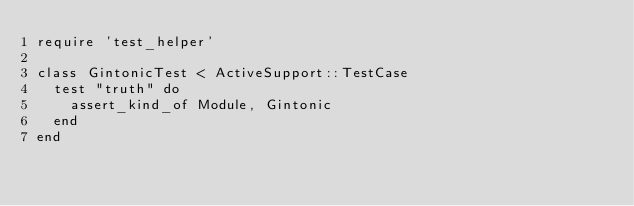Convert code to text. <code><loc_0><loc_0><loc_500><loc_500><_Ruby_>require 'test_helper'

class GintonicTest < ActiveSupport::TestCase
  test "truth" do
    assert_kind_of Module, Gintonic
  end
end
</code> 